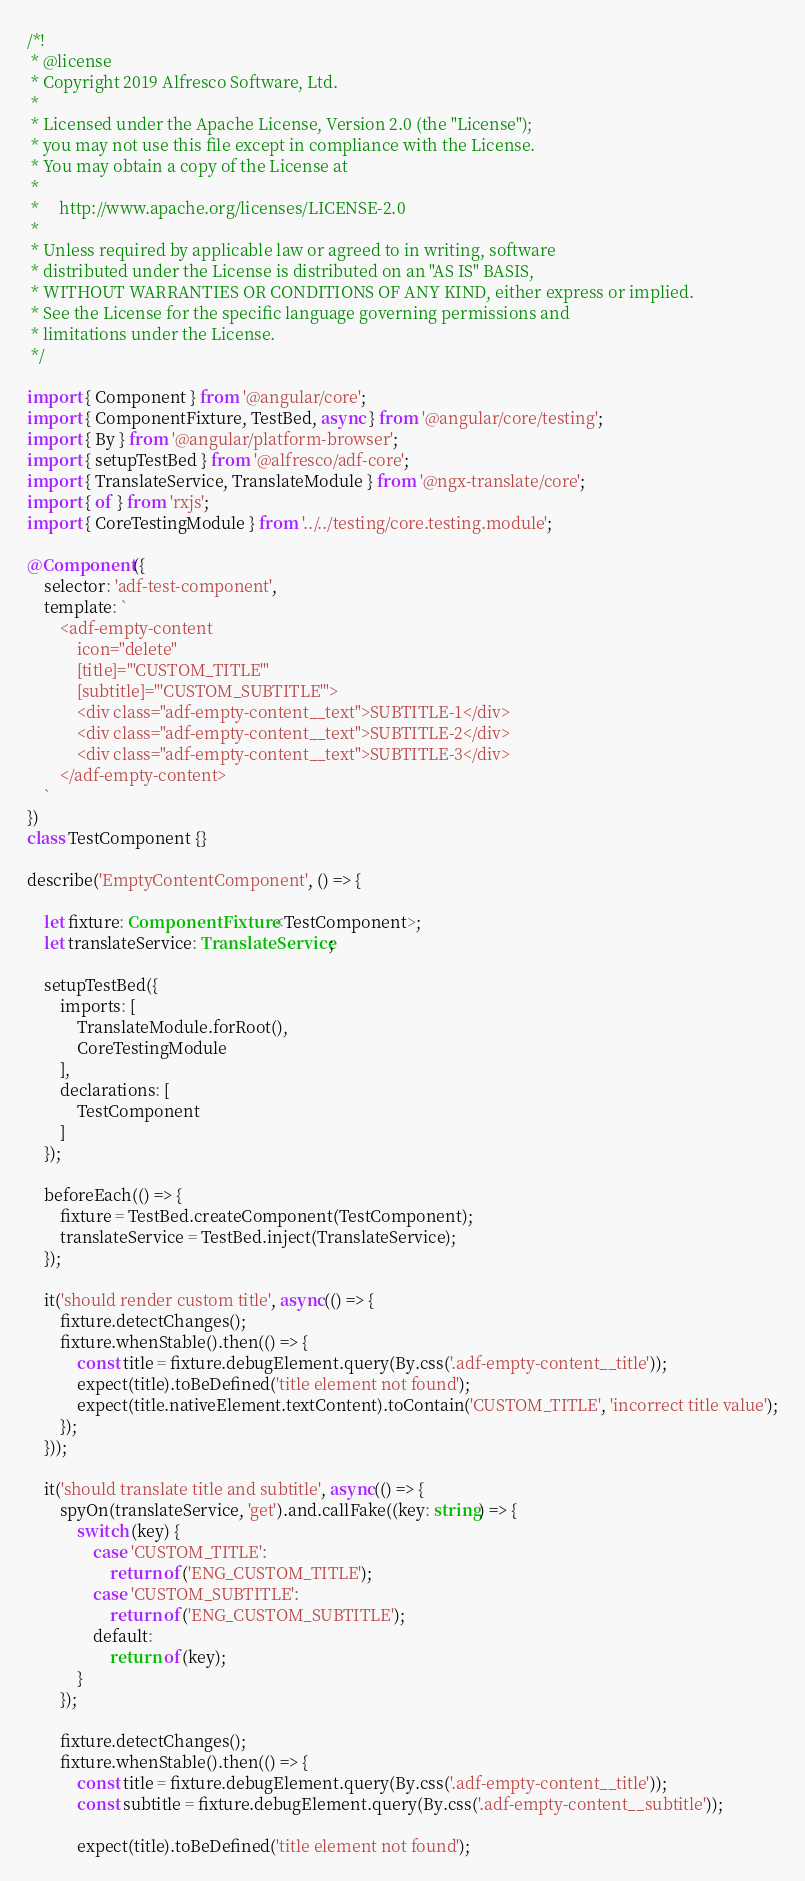Convert code to text. <code><loc_0><loc_0><loc_500><loc_500><_TypeScript_>/*!
 * @license
 * Copyright 2019 Alfresco Software, Ltd.
 *
 * Licensed under the Apache License, Version 2.0 (the "License");
 * you may not use this file except in compliance with the License.
 * You may obtain a copy of the License at
 *
 *     http://www.apache.org/licenses/LICENSE-2.0
 *
 * Unless required by applicable law or agreed to in writing, software
 * distributed under the License is distributed on an "AS IS" BASIS,
 * WITHOUT WARRANTIES OR CONDITIONS OF ANY KIND, either express or implied.
 * See the License for the specific language governing permissions and
 * limitations under the License.
 */

import { Component } from '@angular/core';
import { ComponentFixture, TestBed, async } from '@angular/core/testing';
import { By } from '@angular/platform-browser';
import { setupTestBed } from '@alfresco/adf-core';
import { TranslateService, TranslateModule } from '@ngx-translate/core';
import { of } from 'rxjs';
import { CoreTestingModule } from '../../testing/core.testing.module';

@Component({
    selector: 'adf-test-component',
    template: `
        <adf-empty-content
            icon="delete"
            [title]="'CUSTOM_TITLE'"
            [subtitle]="'CUSTOM_SUBTITLE'">
            <div class="adf-empty-content__text">SUBTITLE-1</div>
            <div class="adf-empty-content__text">SUBTITLE-2</div>
            <div class="adf-empty-content__text">SUBTITLE-3</div>
        </adf-empty-content>
    `
})
class TestComponent {}

describe('EmptyContentComponent', () => {

    let fixture: ComponentFixture<TestComponent>;
    let translateService: TranslateService;

    setupTestBed({
        imports: [
            TranslateModule.forRoot(),
            CoreTestingModule
        ],
        declarations: [
            TestComponent
        ]
    });

    beforeEach(() => {
        fixture = TestBed.createComponent(TestComponent);
        translateService = TestBed.inject(TranslateService);
    });

    it('should render custom title', async(() => {
        fixture.detectChanges();
        fixture.whenStable().then(() => {
            const title = fixture.debugElement.query(By.css('.adf-empty-content__title'));
            expect(title).toBeDefined('title element not found');
            expect(title.nativeElement.textContent).toContain('CUSTOM_TITLE', 'incorrect title value');
        });
    }));

    it('should translate title and subtitle', async(() => {
        spyOn(translateService, 'get').and.callFake((key: string) => {
            switch (key) {
                case 'CUSTOM_TITLE':
                    return of('ENG_CUSTOM_TITLE');
                case 'CUSTOM_SUBTITLE':
                    return of('ENG_CUSTOM_SUBTITLE');
                default:
                    return of(key);
            }
        });

        fixture.detectChanges();
        fixture.whenStable().then(() => {
            const title = fixture.debugElement.query(By.css('.adf-empty-content__title'));
            const subtitle = fixture.debugElement.query(By.css('.adf-empty-content__subtitle'));

            expect(title).toBeDefined('title element not found');</code> 